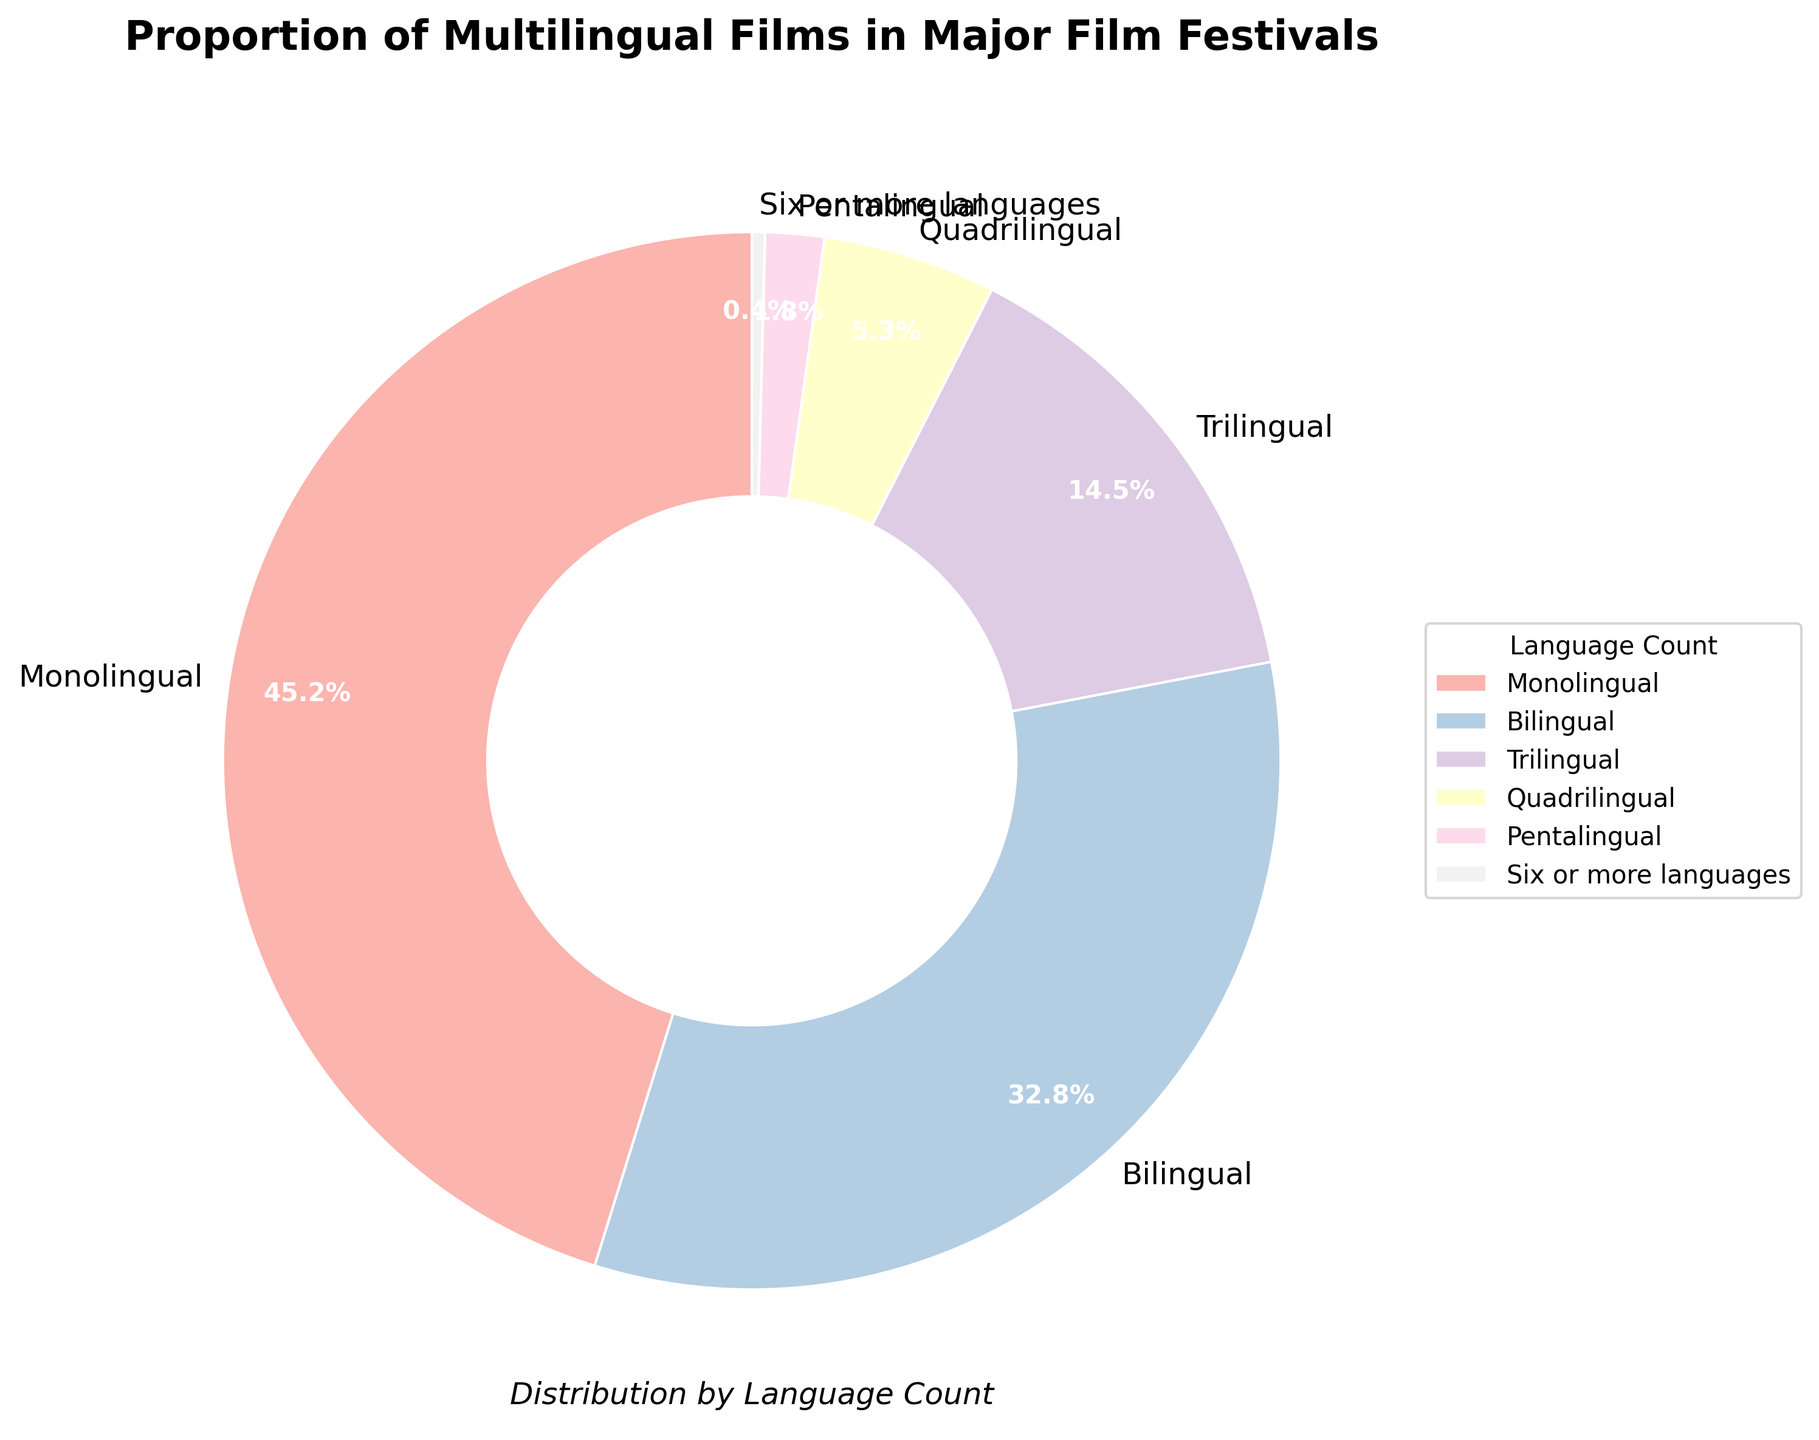What's the proportion of monolingual films? The figure displays different language counts and their proportions. For monolingual films, the proportion is directly shown on the pie chart.
Answer: 45.2% Which language count has the smallest proportion? Look at the pie chart and identify the slice with the smallest proportion. The label "Six or more languages" indicates 0.4%, which is the smallest.
Answer: Six or more languages How much more common are monolingual films compared to bilingual films? Monolingual films have a proportion of 45.2%, and bilingual films have 32.8%. Subtract the proportion of bilingual films from the proportion of monolingual films: 45.2% - 32.8% = 12.4%.
Answer: 12.4% What is the combined proportion of trilingual and quadrilingual films? The pie chart shows 14.5% for trilingual and 5.3% for quadrilingual films. Add these proportions: 14.5% + 5.3% = 19.8%.
Answer: 19.8% Which has a higher proportion, pentalingual films or trilingual films? Compare the proportions shown on the pie chart: pentalingual films have 1.8%, and trilingual films have 14.5%. Trilingual films have a higher proportion.
Answer: Trilingual films What's the difference in proportion between quadrilingual and pentalingual films? Quadrilingual films have a proportion of 5.3%, and pentalingual films have 1.8%. Subtract the proportion of pentalingual films from quadrilingual films: 5.3% - 1.8% = 3.5%.
Answer: 3.5% What proportion of films are multilingual (i.e., bilingual or more)? To find the proportion of multilingual films, add the proportions of bilingual, trilingual, quadrilingual, pentalingual, and six or more languages: 32.8% + 14.5% + 5.3% + 1.8% + 0.4% = 54.8%.
Answer: 54.8% Which language count category covers the largest segment in the pie chart? Visually inspect the pie chart for the largest segment. "Monolingual" films cover the largest segment with 45.2%.
Answer: Monolingual If you sum the proportions of bilingual and trilingual films, what proportion do you get? Add the proportions of bilingual (32.8%) and trilingual (14.5%) films: 32.8% + 14.5% = 47.3%.
Answer: 47.3% Which slice is colored the lightest? The visual attribute (color) identifies the lightest-colored slice. Typically, lighter colors indicate smaller proportions; therefore, the slice for "Six or more languages" with 0.4% is the lightest.
Answer: Six or more languages 